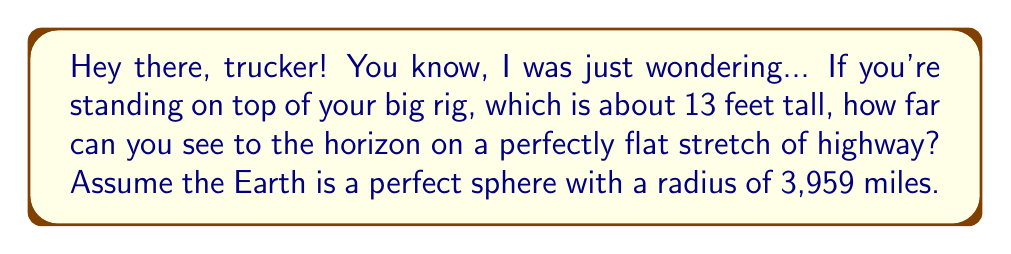Give your solution to this math problem. Alright, let's break this down step-by-step:

1) First, we need to use the Pythagorean theorem. Imagine a right triangle formed by the Earth's radius, the distance to the horizon, and the line from the Earth's center to the horizon point.

2) Let's define our variables:
   $R$ = Earth's radius = 3,959 miles
   $h$ = Height of observer = 13 feet = 13/5280 miles (converting to miles)
   $d$ = Distance to horizon (what we're solving for)

3) Using the Pythagorean theorem:
   $$(R+h)^2 = R^2 + d^2$$

4) Expanding this:
   $$R^2 + 2Rh + h^2 = R^2 + d^2$$

5) Simplifying:
   $$2Rh + h^2 = d^2$$

6) Since $h$ is very small compared to $R$, $h^2$ is negligible. So we can approximate:
   $$2Rh \approx d^2$$

7) Solving for $d$:
   $$d \approx \sqrt{2Rh}$$

8) Plugging in our values:
   $$d \approx \sqrt{2 \cdot 3959 \cdot \frac{13}{5280}}$$

9) Calculating:
   $$d \approx 4.47 \text{ miles}$$

[asy]
import geometry;

unitsize(1cm);

pair O = (0,0);
real R = 5;
real h = 0.5;
real d = sqrt(2*R*h);

path earth = Circle(O, R);
pair P = (0, R+h);
pair H = (d, R);

draw(earth);
draw(O--P, dashed);
draw(O--H, dashed);
draw(P--H);

label("O", O, SW);
label("P", P, N);
label("H", H, E);
label("R", (0, R/2), W);
label("h", (0, R+h/2), E);
label("d", (d/2, R), S);

[/asy]
Answer: 4.47 miles 